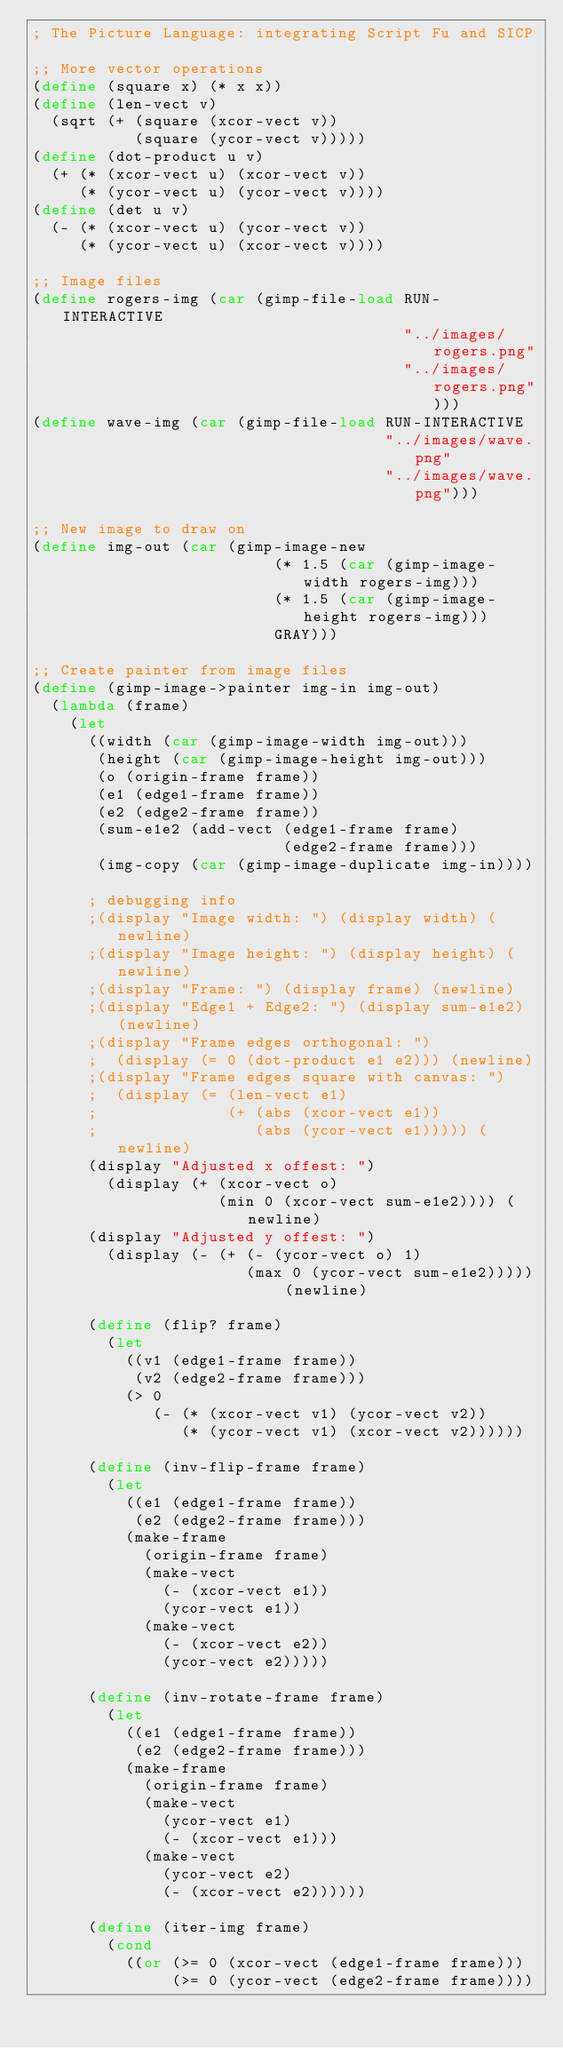<code> <loc_0><loc_0><loc_500><loc_500><_Scheme_>; The Picture Language: integrating Script Fu and SICP

;; More vector operations
(define (square x) (* x x))
(define (len-vect v)
  (sqrt (+ (square (xcor-vect v))
           (square (ycor-vect v)))))
(define (dot-product u v)
  (+ (* (xcor-vect u) (xcor-vect v))
     (* (ycor-vect u) (ycor-vect v))))
(define (det u v)
  (- (* (xcor-vect u) (ycor-vect v))
     (* (ycor-vect u) (xcor-vect v))))

;; Image files
(define rogers-img (car (gimp-file-load RUN-INTERACTIVE
                                        "../images/rogers.png"
                                        "../images/rogers.png")))
(define wave-img (car (gimp-file-load RUN-INTERACTIVE
                                      "../images/wave.png"
                                      "../images/wave.png")))

;; New image to draw on
(define img-out (car (gimp-image-new
                          (* 1.5 (car (gimp-image-width rogers-img)))
                          (* 1.5 (car (gimp-image-height rogers-img)))
                          GRAY)))

;; Create painter from image files
(define (gimp-image->painter img-in img-out)
  (lambda (frame)
    (let
      ((width (car (gimp-image-width img-out)))
       (height (car (gimp-image-height img-out)))
       (o (origin-frame frame))
       (e1 (edge1-frame frame))
       (e2 (edge2-frame frame))
       (sum-e1e2 (add-vect (edge1-frame frame)
                           (edge2-frame frame)))
       (img-copy (car (gimp-image-duplicate img-in))))

      ; debugging info
      ;(display "Image width: ") (display width) (newline)
      ;(display "Image height: ") (display height) (newline)
      ;(display "Frame: ") (display frame) (newline)
      ;(display "Edge1 + Edge2: ") (display sum-e1e2) (newline)
      ;(display "Frame edges orthogonal: ")
      ;  (display (= 0 (dot-product e1 e2))) (newline)
      ;(display "Frame edges square with canvas: ")
      ;  (display (= (len-vect e1)
      ;              (+ (abs (xcor-vect e1))
      ;                 (abs (ycor-vect e1))))) (newline)
      (display "Adjusted x offest: ")
        (display (+ (xcor-vect o)
                    (min 0 (xcor-vect sum-e1e2)))) (newline)
      (display "Adjusted y offest: ")
        (display (- (+ (- (ycor-vect o) 1)
                       (max 0 (ycor-vect sum-e1e2))))) (newline)

      (define (flip? frame)
        (let
          ((v1 (edge1-frame frame))
           (v2 (edge2-frame frame)))
          (> 0 
             (- (* (xcor-vect v1) (ycor-vect v2))
                (* (ycor-vect v1) (xcor-vect v2))))))

      (define (inv-flip-frame frame)
        (let
          ((e1 (edge1-frame frame))
           (e2 (edge2-frame frame)))
          (make-frame
            (origin-frame frame)
            (make-vect
              (- (xcor-vect e1))
              (ycor-vect e1))
            (make-vect
              (- (xcor-vect e2))
              (ycor-vect e2)))))

      (define (inv-rotate-frame frame)
        (let
          ((e1 (edge1-frame frame))
           (e2 (edge2-frame frame)))
          (make-frame
            (origin-frame frame)
            (make-vect
              (ycor-vect e1)
              (- (xcor-vect e1)))
            (make-vect
              (ycor-vect e2)
              (- (xcor-vect e2))))))

      (define (iter-img frame)
        (cond
          ((or (>= 0 (xcor-vect (edge1-frame frame)))
               (>= 0 (ycor-vect (edge2-frame frame))))</code> 